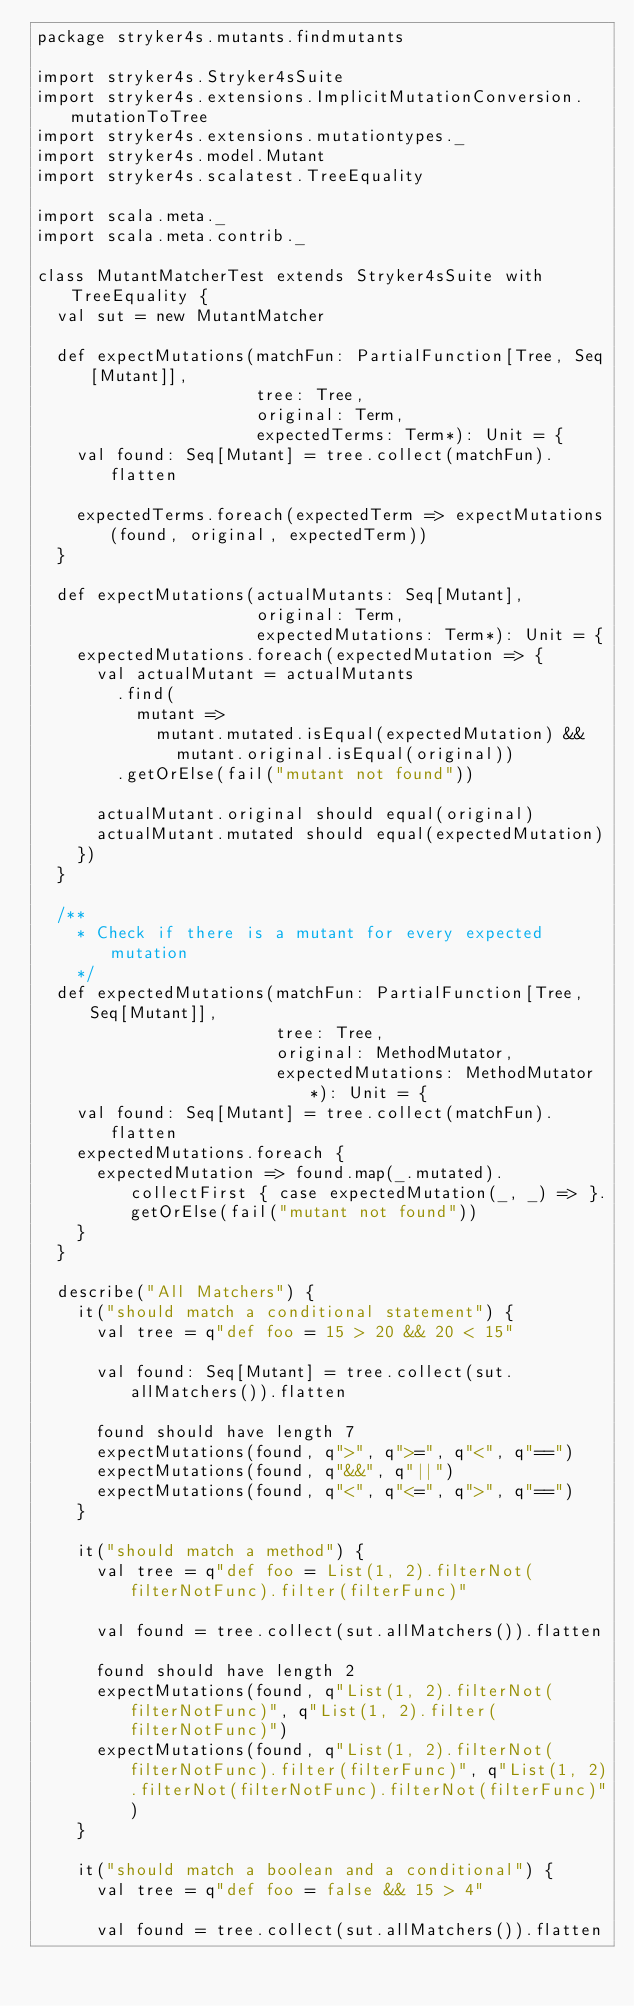<code> <loc_0><loc_0><loc_500><loc_500><_Scala_>package stryker4s.mutants.findmutants

import stryker4s.Stryker4sSuite
import stryker4s.extensions.ImplicitMutationConversion.mutationToTree
import stryker4s.extensions.mutationtypes._
import stryker4s.model.Mutant
import stryker4s.scalatest.TreeEquality

import scala.meta._
import scala.meta.contrib._

class MutantMatcherTest extends Stryker4sSuite with TreeEquality {
  val sut = new MutantMatcher

  def expectMutations(matchFun: PartialFunction[Tree, Seq[Mutant]],
                      tree: Tree,
                      original: Term,
                      expectedTerms: Term*): Unit = {
    val found: Seq[Mutant] = tree.collect(matchFun).flatten

    expectedTerms.foreach(expectedTerm => expectMutations(found, original, expectedTerm))
  }

  def expectMutations(actualMutants: Seq[Mutant],
                      original: Term,
                      expectedMutations: Term*): Unit = {
    expectedMutations.foreach(expectedMutation => {
      val actualMutant = actualMutants
        .find(
          mutant =>
            mutant.mutated.isEqual(expectedMutation) &&
              mutant.original.isEqual(original))
        .getOrElse(fail("mutant not found"))

      actualMutant.original should equal(original)
      actualMutant.mutated should equal(expectedMutation)
    })
  }

  /**
    * Check if there is a mutant for every expected mutation
    */
  def expectedMutations(matchFun: PartialFunction[Tree, Seq[Mutant]],
                        tree: Tree,
                        original: MethodMutator,
                        expectedMutations: MethodMutator*): Unit = {
    val found: Seq[Mutant] = tree.collect(matchFun).flatten
    expectedMutations.foreach {
      expectedMutation => found.map(_.mutated).collectFirst { case expectedMutation(_, _) => }.getOrElse(fail("mutant not found"))
    }
  }

  describe("All Matchers") {
    it("should match a conditional statement") {
      val tree = q"def foo = 15 > 20 && 20 < 15"

      val found: Seq[Mutant] = tree.collect(sut.allMatchers()).flatten

      found should have length 7
      expectMutations(found, q">", q">=", q"<", q"==")
      expectMutations(found, q"&&", q"||")
      expectMutations(found, q"<", q"<=", q">", q"==")
    }

    it("should match a method") {
      val tree = q"def foo = List(1, 2).filterNot(filterNotFunc).filter(filterFunc)"

      val found = tree.collect(sut.allMatchers()).flatten

      found should have length 2
      expectMutations(found, q"List(1, 2).filterNot(filterNotFunc)", q"List(1, 2).filter(filterNotFunc)")
      expectMutations(found, q"List(1, 2).filterNot(filterNotFunc).filter(filterFunc)", q"List(1, 2).filterNot(filterNotFunc).filterNot(filterFunc)")
    }

    it("should match a boolean and a conditional") {
      val tree = q"def foo = false && 15 > 4"

      val found = tree.collect(sut.allMatchers()).flatten
</code> 